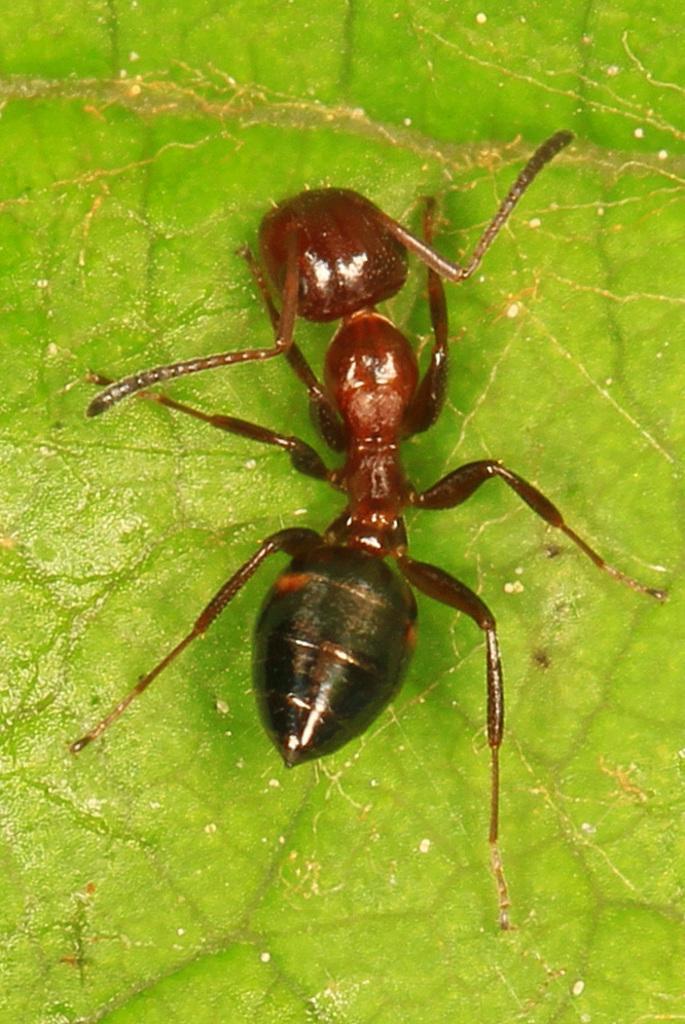Can you describe this image briefly? In this image there is an ant on a leaf. 